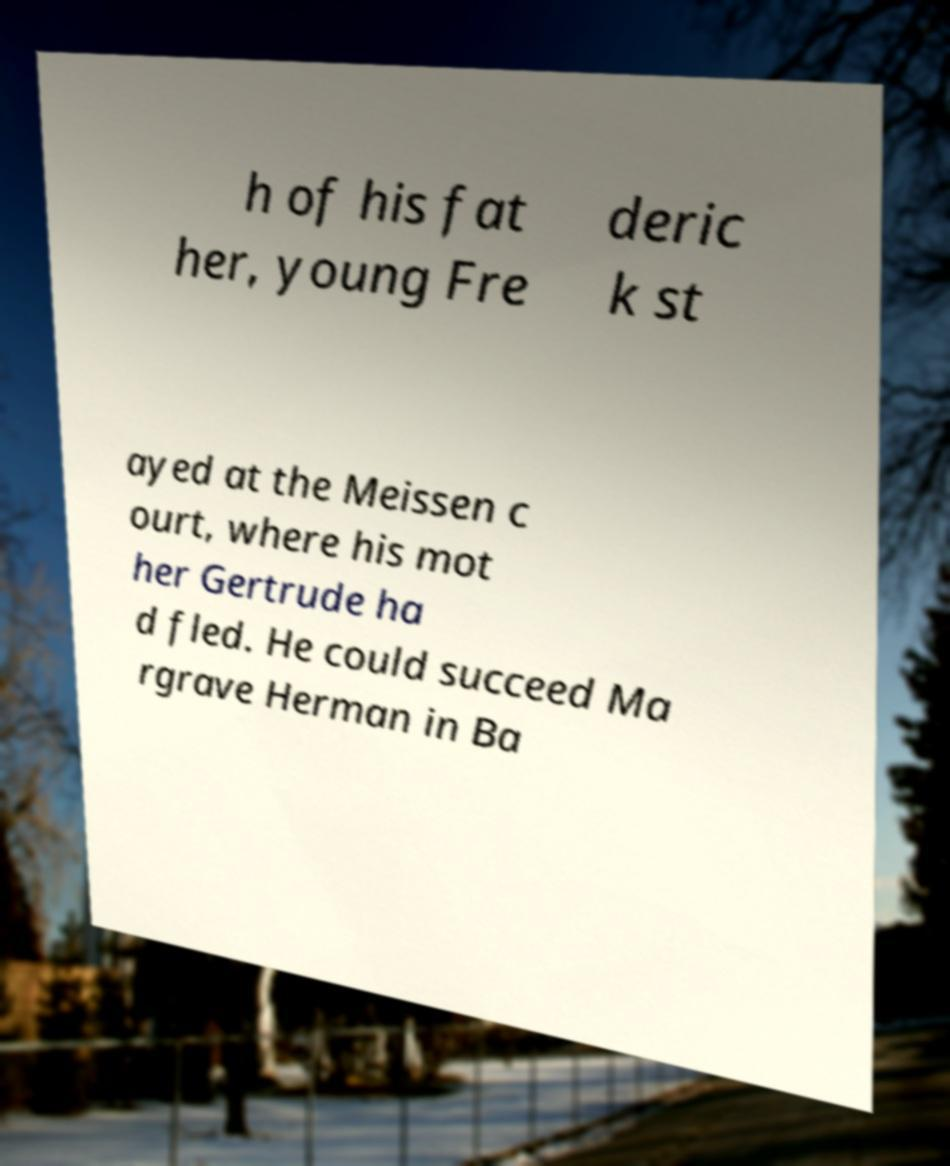Could you assist in decoding the text presented in this image and type it out clearly? h of his fat her, young Fre deric k st ayed at the Meissen c ourt, where his mot her Gertrude ha d fled. He could succeed Ma rgrave Herman in Ba 